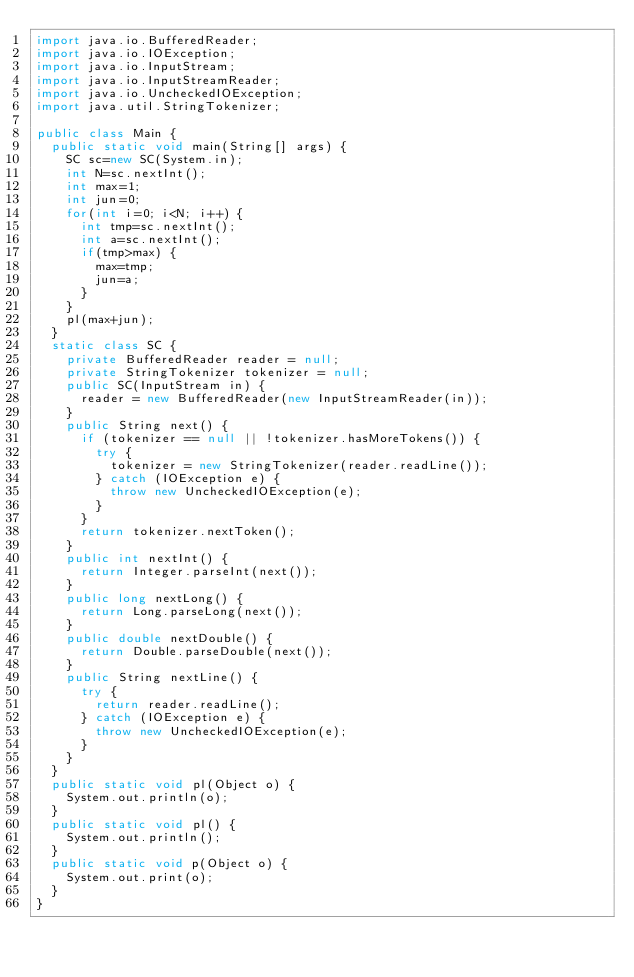Convert code to text. <code><loc_0><loc_0><loc_500><loc_500><_Java_>import java.io.BufferedReader;
import java.io.IOException;
import java.io.InputStream;
import java.io.InputStreamReader;
import java.io.UncheckedIOException;
import java.util.StringTokenizer;

public class Main {
	public static void main(String[] args) {
		SC sc=new SC(System.in);
		int N=sc.nextInt();
		int max=1;
		int jun=0;
		for(int i=0; i<N; i++) {
			int tmp=sc.nextInt();
			int a=sc.nextInt();
			if(tmp>max) {
				max=tmp;
				jun=a;
			}
		}
		pl(max+jun);
	}
	static class SC {
		private BufferedReader reader = null;
		private StringTokenizer tokenizer = null;
		public SC(InputStream in) {
			reader = new BufferedReader(new InputStreamReader(in));
		}
		public String next() {
			if (tokenizer == null || !tokenizer.hasMoreTokens()) {
				try {
					tokenizer = new StringTokenizer(reader.readLine());
				} catch (IOException e) {
					throw new UncheckedIOException(e);
				}
			}
			return tokenizer.nextToken();
		}
		public int nextInt() {
			return Integer.parseInt(next());
		}
		public long nextLong() {
			return Long.parseLong(next());
		}
		public double nextDouble() {
			return Double.parseDouble(next());
		}
		public String nextLine() {
			try {
				return reader.readLine();
			} catch (IOException e) {
				throw new UncheckedIOException(e);
			}
		}
	}
	public static void pl(Object o) {
		System.out.println(o);
	}
	public static void pl() {
		System.out.println();
	}
	public static void p(Object o) {
		System.out.print(o);
	}
}
</code> 